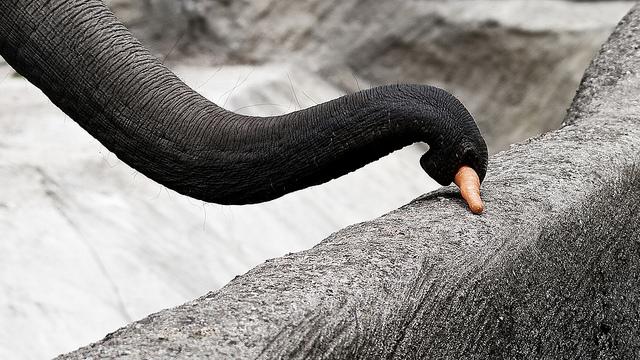What is the object near the elephants nose?
Be succinct. Carrot. Where is the elephant?
Answer briefly. Zoo. What color is the elephant?
Write a very short answer. Gray. Is the elephant touching the wall with a vegetable in his nose?
Keep it brief. Yes. What kind of animal is holding the carrot?
Short answer required. Elephant. 